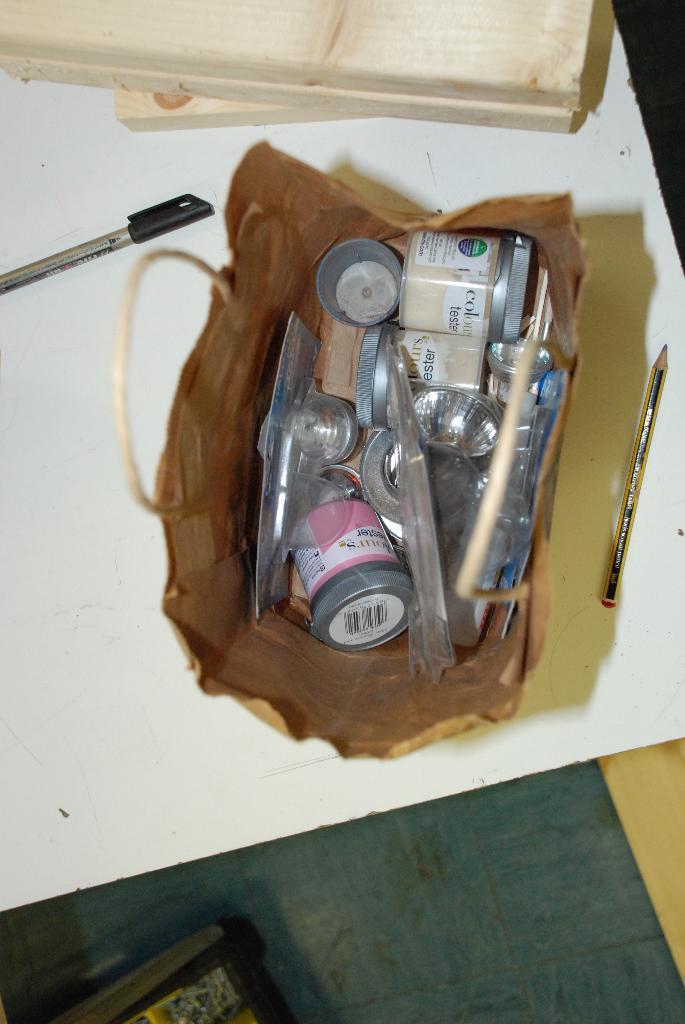Describe this image in one or two sentences. In this image we can see many objects in a bag. There is a pen on the table at the left side of the image. There is a pencil on the table at the right side of the image. There are few books on the table at the top of the image. There is an object at the bottom of the image. 